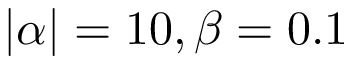<formula> <loc_0><loc_0><loc_500><loc_500>| \alpha | = 1 0 , \beta = 0 . 1</formula> 